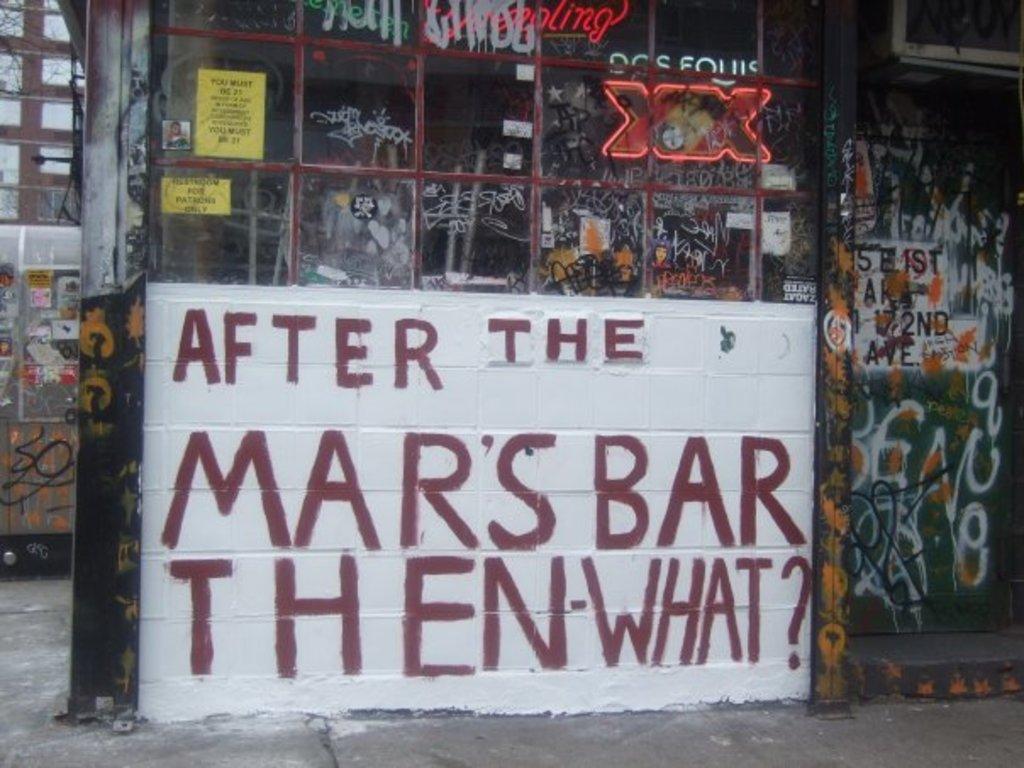Could you give a brief overview of what you see in this image? In this image we can see a wall on which some text was written, posters are pasted on it and some digital text is displayed. 